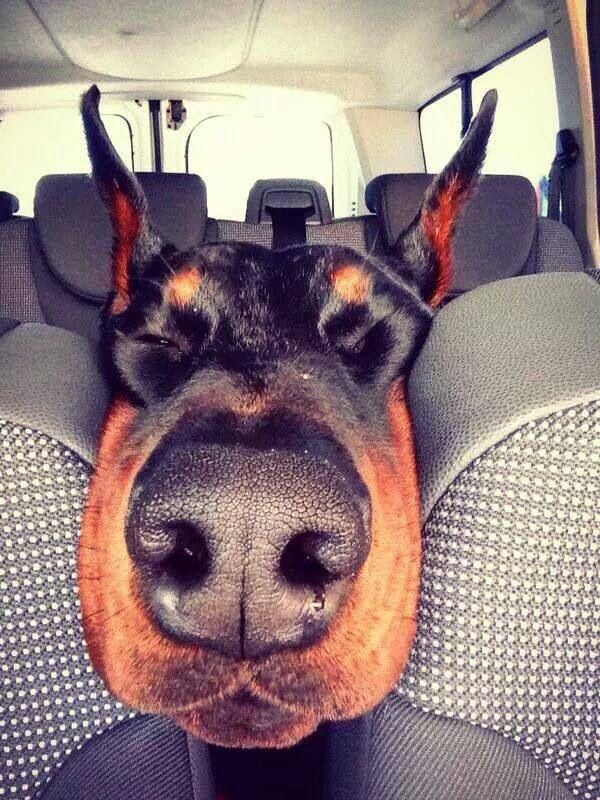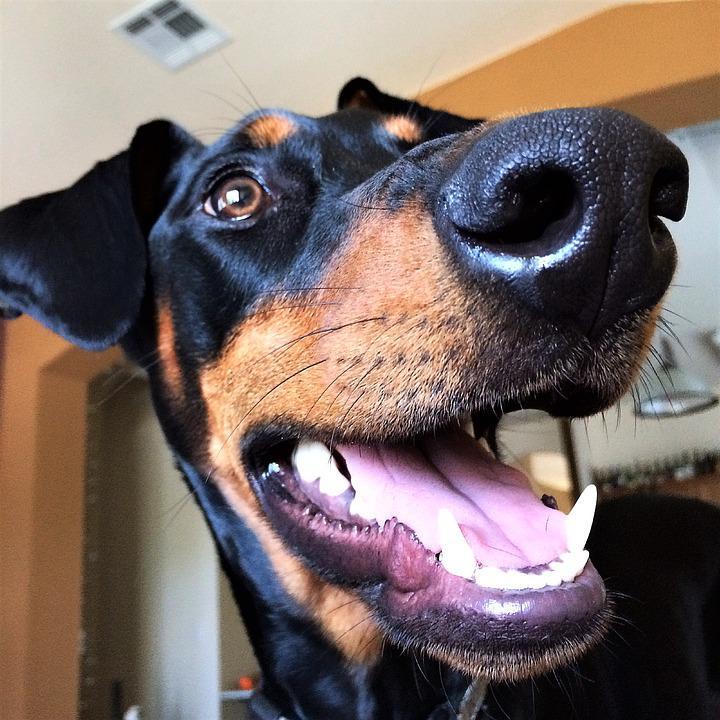The first image is the image on the left, the second image is the image on the right. For the images shown, is this caption "There are exactly three dogs in total." true? Answer yes or no. No. The first image is the image on the left, the second image is the image on the right. For the images displayed, is the sentence "There are 3 dogs in cars." factually correct? Answer yes or no. No. 